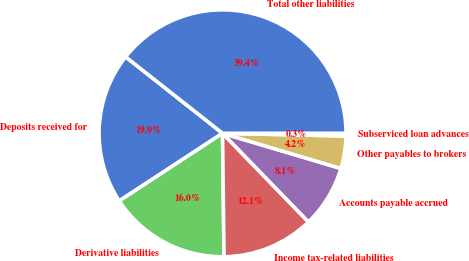Convert chart to OTSL. <chart><loc_0><loc_0><loc_500><loc_500><pie_chart><fcel>Deposits received for<fcel>Derivative liabilities<fcel>Income tax-related liabilities<fcel>Accounts payable accrued<fcel>Other payables to brokers<fcel>Subserviced loan advances<fcel>Total other liabilities<nl><fcel>19.86%<fcel>15.96%<fcel>12.06%<fcel>8.15%<fcel>4.25%<fcel>0.35%<fcel>39.37%<nl></chart> 